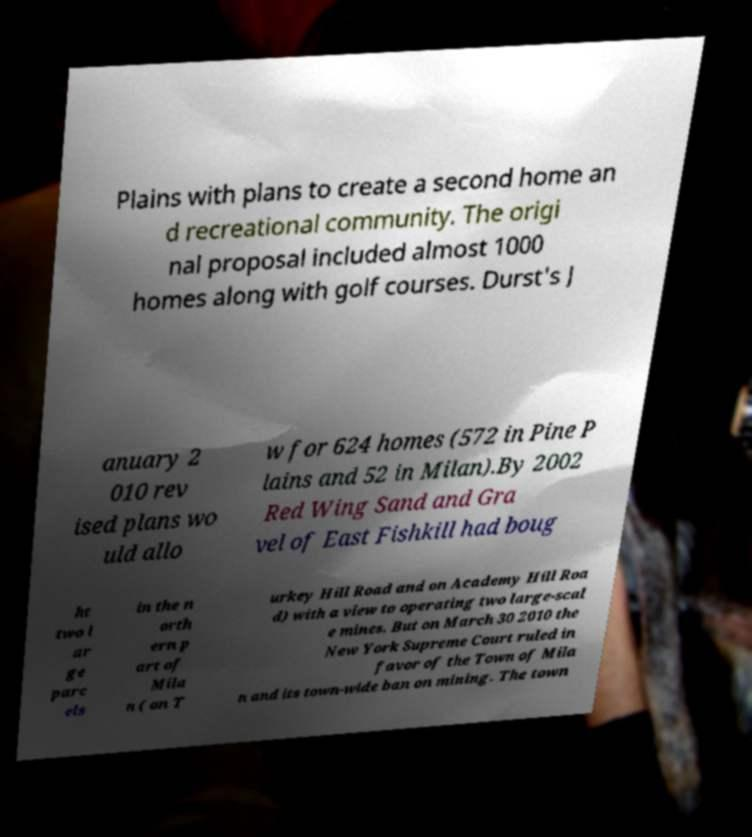I need the written content from this picture converted into text. Can you do that? Plains with plans to create a second home an d recreational community. The origi nal proposal included almost 1000 homes along with golf courses. Durst's J anuary 2 010 rev ised plans wo uld allo w for 624 homes (572 in Pine P lains and 52 in Milan).By 2002 Red Wing Sand and Gra vel of East Fishkill had boug ht two l ar ge parc els in the n orth ern p art of Mila n ( on T urkey Hill Road and on Academy Hill Roa d) with a view to operating two large-scal e mines. But on March 30 2010 the New York Supreme Court ruled in favor of the Town of Mila n and its town-wide ban on mining. The town 